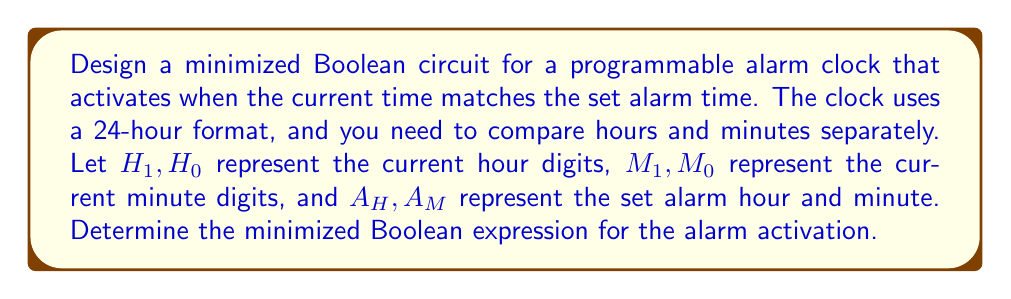Provide a solution to this math problem. Let's approach this step-by-step:

1) We need to compare two sets of values:
   - Current hour $(H_1H_0)$ with alarm hour $(A_H)$
   - Current minute $(M_1M_0)$ with alarm minute $(A_M)$

2) The alarm should activate when both hour and minute match. We can represent this as:

   $Alarm = (H_1H_0 = A_H) \land (M_1M_0 = A_M)$

3) For the hour comparison:
   $$(H_1H_0 = A_H) = (H_1 \leftrightarrow A_{H1}) \land (H_0 \leftrightarrow A_{H0})$$

4) Similarly for the minute comparison:
   $$(M_1M_0 = A_M) = (M_1 \leftrightarrow A_{M1}) \land (M_0 \leftrightarrow A_{M0})$$

5) The complete expression becomes:
   $$Alarm = ((H_1 \leftrightarrow A_{H1}) \land (H_0 \leftrightarrow A_{H0})) \land ((M_1 \leftrightarrow A_{M1}) \land (M_0 \leftrightarrow A_{M0}))$$

6) We can simplify each XNOR operation:
   $$(X \leftrightarrow Y) = (X \land Y) \lor (\overline{X} \land \overline{Y})$$

7) Applying this to our expression:
   $$Alarm = ((H_1A_{H1} \lor \overline{H_1}\overline{A_{H1}}) \land (H_0A_{H0} \lor \overline{H_0}\overline{A_{H0}})) \land ((M_1A_{M1} \lor \overline{M_1}\overline{A_{M1}}) \land (M_0A_{M0} \lor \overline{M_0}\overline{A_{M0}}))$$

This is the minimized Boolean expression for the alarm activation.
Answer: $((H_1A_{H1} \lor \overline{H_1}\overline{A_{H1}}) \land (H_0A_{H0} \lor \overline{H_0}\overline{A_{H0}})) \land ((M_1A_{M1} \lor \overline{M_1}\overline{A_{M1}}) \land (M_0A_{M0} \lor \overline{M_0}\overline{A_{M0}}))$ 